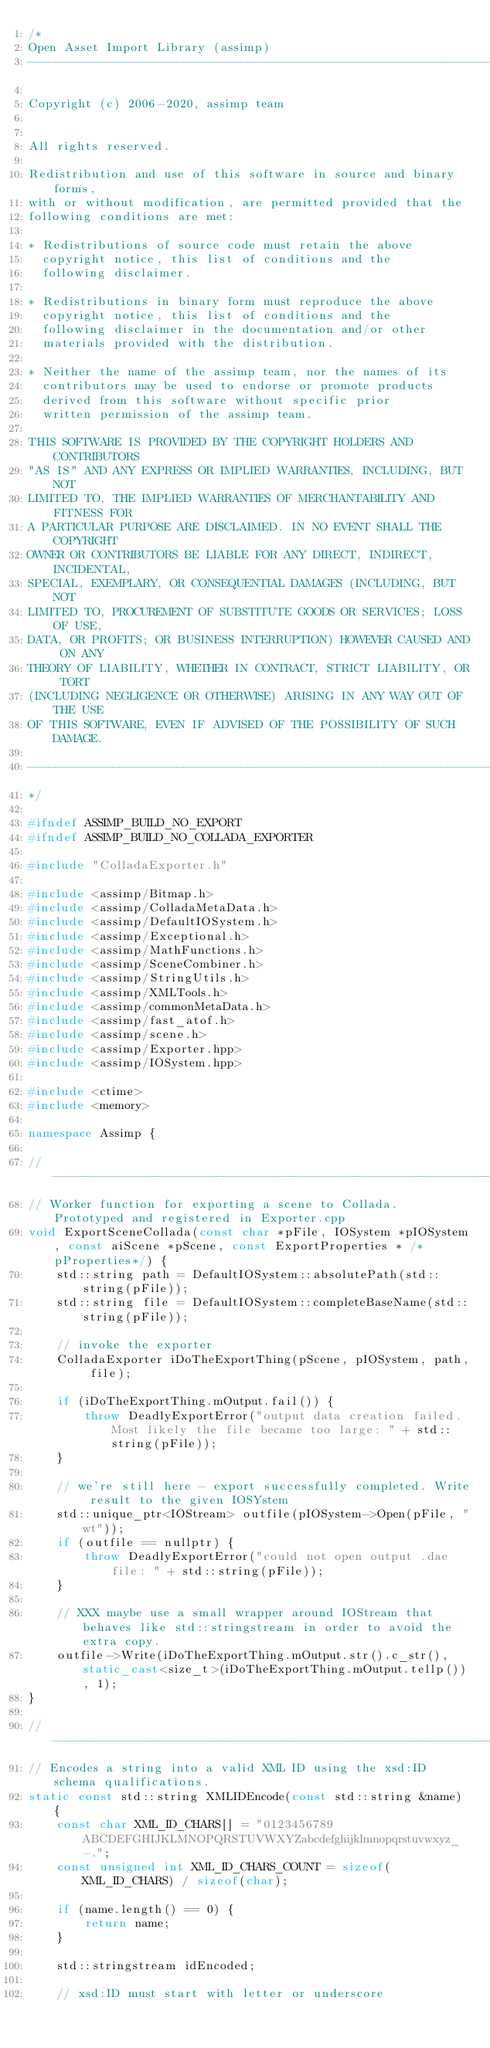Convert code to text. <code><loc_0><loc_0><loc_500><loc_500><_C++_>/*
Open Asset Import Library (assimp)
----------------------------------------------------------------------

Copyright (c) 2006-2020, assimp team


All rights reserved.

Redistribution and use of this software in source and binary forms,
with or without modification, are permitted provided that the
following conditions are met:

* Redistributions of source code must retain the above
  copyright notice, this list of conditions and the
  following disclaimer.

* Redistributions in binary form must reproduce the above
  copyright notice, this list of conditions and the
  following disclaimer in the documentation and/or other
  materials provided with the distribution.

* Neither the name of the assimp team, nor the names of its
  contributors may be used to endorse or promote products
  derived from this software without specific prior
  written permission of the assimp team.

THIS SOFTWARE IS PROVIDED BY THE COPYRIGHT HOLDERS AND CONTRIBUTORS
"AS IS" AND ANY EXPRESS OR IMPLIED WARRANTIES, INCLUDING, BUT NOT
LIMITED TO, THE IMPLIED WARRANTIES OF MERCHANTABILITY AND FITNESS FOR
A PARTICULAR PURPOSE ARE DISCLAIMED. IN NO EVENT SHALL THE COPYRIGHT
OWNER OR CONTRIBUTORS BE LIABLE FOR ANY DIRECT, INDIRECT, INCIDENTAL,
SPECIAL, EXEMPLARY, OR CONSEQUENTIAL DAMAGES (INCLUDING, BUT NOT
LIMITED TO, PROCUREMENT OF SUBSTITUTE GOODS OR SERVICES; LOSS OF USE,
DATA, OR PROFITS; OR BUSINESS INTERRUPTION) HOWEVER CAUSED AND ON ANY
THEORY OF LIABILITY, WHETHER IN CONTRACT, STRICT LIABILITY, OR TORT
(INCLUDING NEGLIGENCE OR OTHERWISE) ARISING IN ANY WAY OUT OF THE USE
OF THIS SOFTWARE, EVEN IF ADVISED OF THE POSSIBILITY OF SUCH DAMAGE.

----------------------------------------------------------------------
*/

#ifndef ASSIMP_BUILD_NO_EXPORT
#ifndef ASSIMP_BUILD_NO_COLLADA_EXPORTER

#include "ColladaExporter.h"

#include <assimp/Bitmap.h>
#include <assimp/ColladaMetaData.h>
#include <assimp/DefaultIOSystem.h>
#include <assimp/Exceptional.h>
#include <assimp/MathFunctions.h>
#include <assimp/SceneCombiner.h>
#include <assimp/StringUtils.h>
#include <assimp/XMLTools.h>
#include <assimp/commonMetaData.h>
#include <assimp/fast_atof.h>
#include <assimp/scene.h>
#include <assimp/Exporter.hpp>
#include <assimp/IOSystem.hpp>

#include <ctime>
#include <memory>

namespace Assimp {

// ------------------------------------------------------------------------------------------------
// Worker function for exporting a scene to Collada. Prototyped and registered in Exporter.cpp
void ExportSceneCollada(const char *pFile, IOSystem *pIOSystem, const aiScene *pScene, const ExportProperties * /*pProperties*/) {
    std::string path = DefaultIOSystem::absolutePath(std::string(pFile));
    std::string file = DefaultIOSystem::completeBaseName(std::string(pFile));

    // invoke the exporter
    ColladaExporter iDoTheExportThing(pScene, pIOSystem, path, file);

    if (iDoTheExportThing.mOutput.fail()) {
        throw DeadlyExportError("output data creation failed. Most likely the file became too large: " + std::string(pFile));
    }

    // we're still here - export successfully completed. Write result to the given IOSYstem
    std::unique_ptr<IOStream> outfile(pIOSystem->Open(pFile, "wt"));
    if (outfile == nullptr) {
        throw DeadlyExportError("could not open output .dae file: " + std::string(pFile));
    }

    // XXX maybe use a small wrapper around IOStream that behaves like std::stringstream in order to avoid the extra copy.
    outfile->Write(iDoTheExportThing.mOutput.str().c_str(), static_cast<size_t>(iDoTheExportThing.mOutput.tellp()), 1);
}

// ------------------------------------------------------------------------------------------------
// Encodes a string into a valid XML ID using the xsd:ID schema qualifications.
static const std::string XMLIDEncode(const std::string &name) {
    const char XML_ID_CHARS[] = "0123456789ABCDEFGHIJKLMNOPQRSTUVWXYZabcdefghijklmnopqrstuvwxyz_-.";
    const unsigned int XML_ID_CHARS_COUNT = sizeof(XML_ID_CHARS) / sizeof(char);

    if (name.length() == 0) {
        return name;
    }

    std::stringstream idEncoded;

    // xsd:ID must start with letter or underscore</code> 